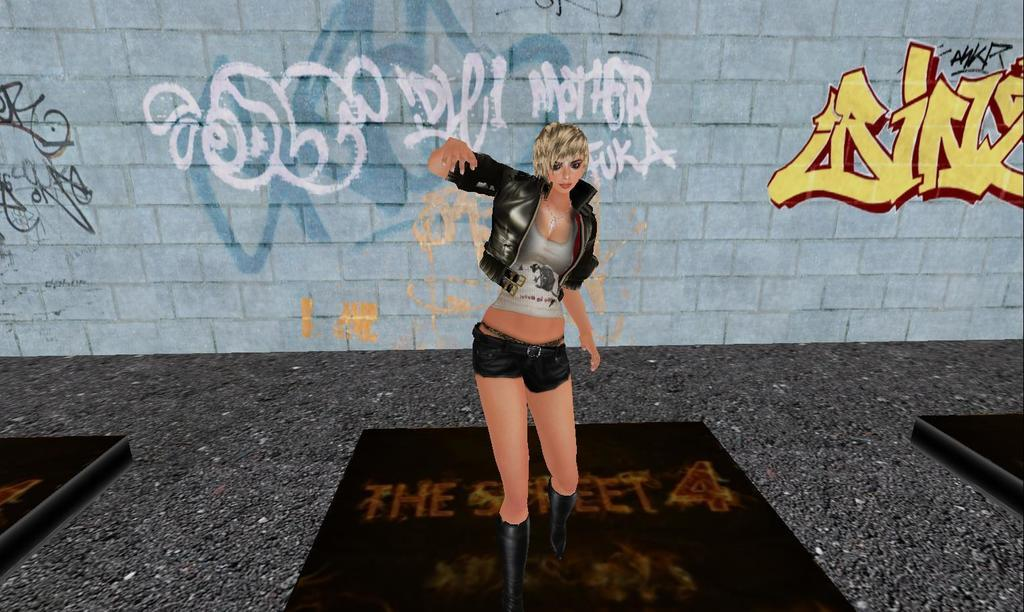Who is the main subject in the image? There is a woman in the image. What is the woman doing in the image? The woman is standing on the floor. What is the woman wearing in the image? The woman is wearing a jacket. What is behind the woman in the image? There is a wall behind the woman. What is written or depicted on the wall? The wall has text on it. What type of nut is being used as a prop in the image? There is no nut present in the image. 